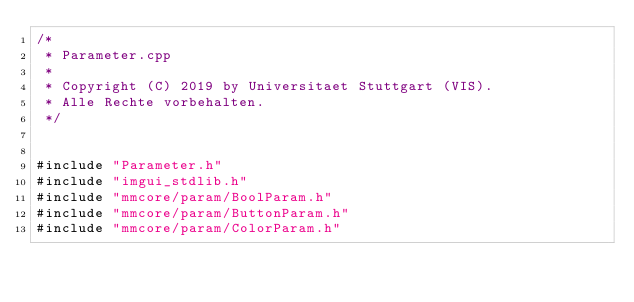Convert code to text. <code><loc_0><loc_0><loc_500><loc_500><_C++_>/*
 * Parameter.cpp
 *
 * Copyright (C) 2019 by Universitaet Stuttgart (VIS).
 * Alle Rechte vorbehalten.
 */


#include "Parameter.h"
#include "imgui_stdlib.h"
#include "mmcore/param/BoolParam.h"
#include "mmcore/param/ButtonParam.h"
#include "mmcore/param/ColorParam.h"</code> 